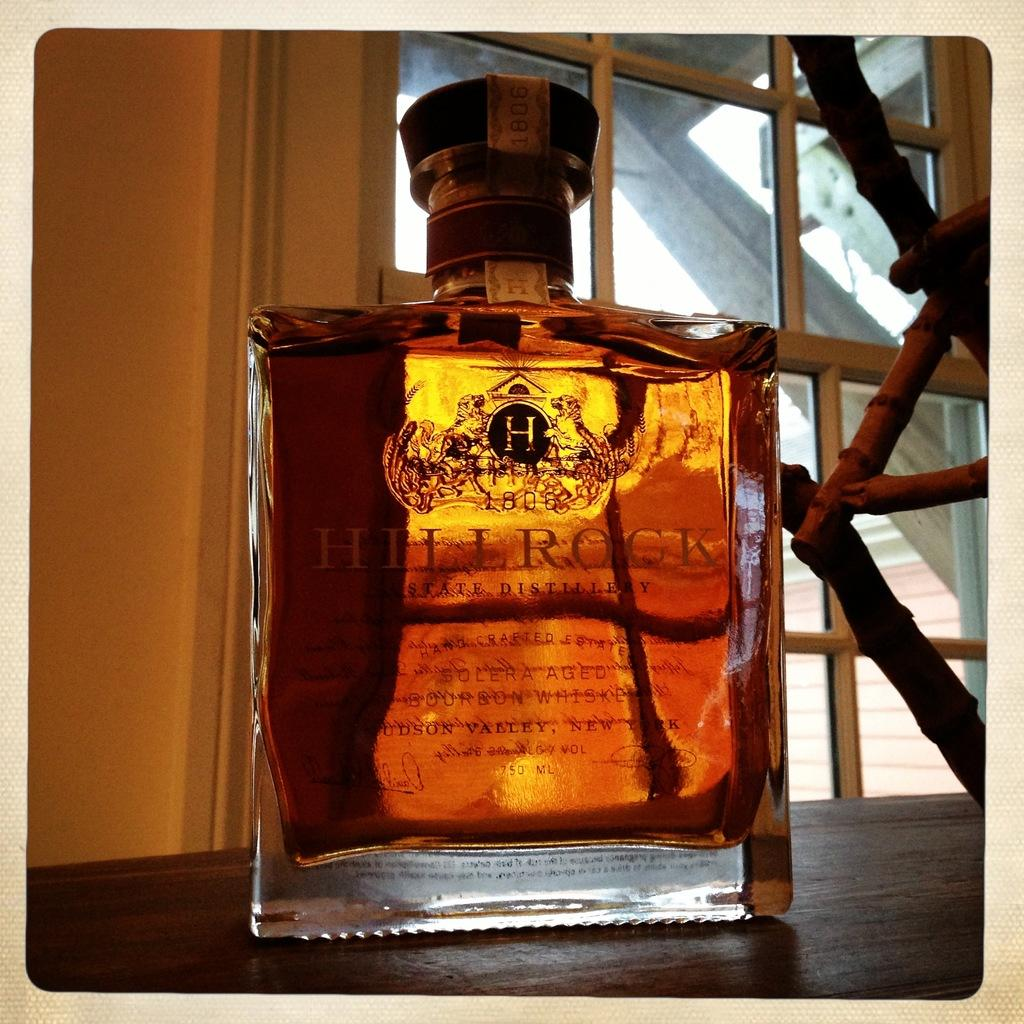<image>
Provide a brief description of the given image. A bottle of Hill Rock is shown in front of a window. 